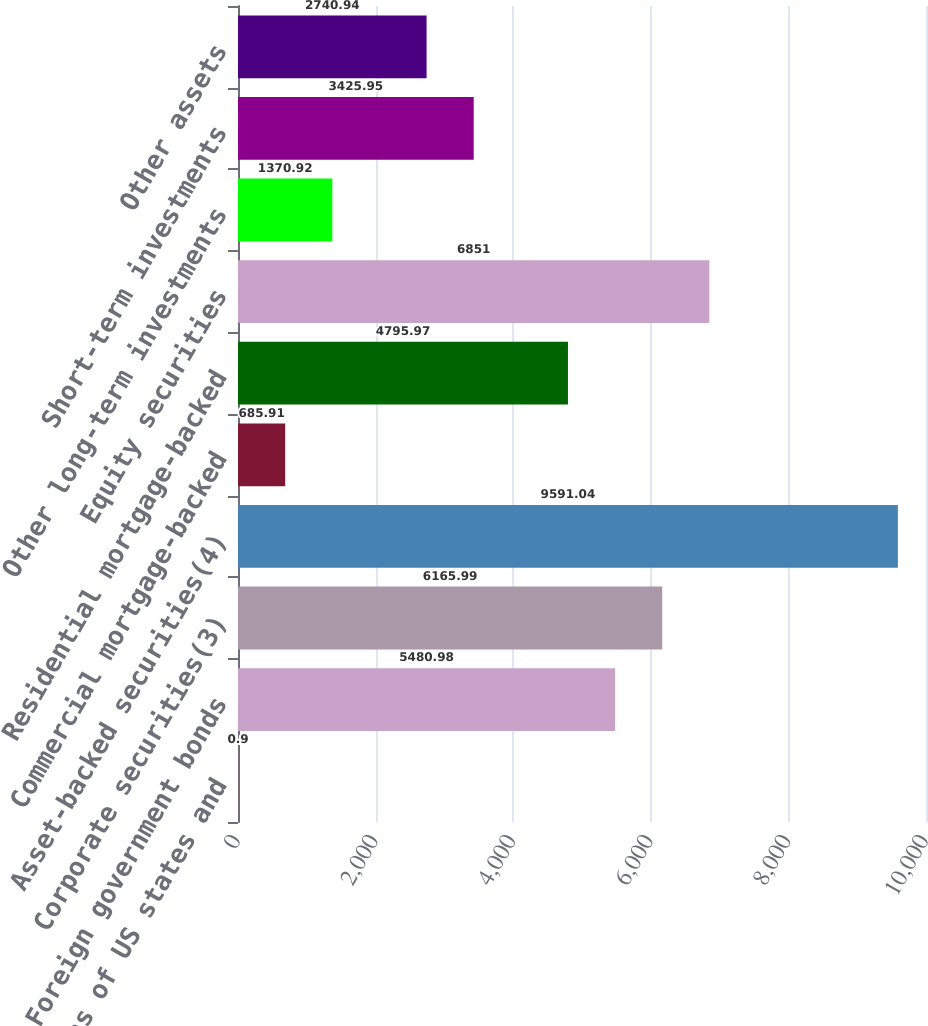Convert chart to OTSL. <chart><loc_0><loc_0><loc_500><loc_500><bar_chart><fcel>Obligations of US states and<fcel>Foreign government bonds<fcel>Corporate securities(3)<fcel>Asset-backed securities(4)<fcel>Commercial mortgage-backed<fcel>Residential mortgage-backed<fcel>Equity securities<fcel>Other long-term investments<fcel>Short-term investments<fcel>Other assets<nl><fcel>0.9<fcel>5480.98<fcel>6165.99<fcel>9591.04<fcel>685.91<fcel>4795.97<fcel>6851<fcel>1370.92<fcel>3425.95<fcel>2740.94<nl></chart> 